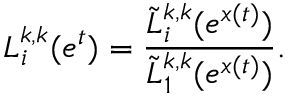Convert formula to latex. <formula><loc_0><loc_0><loc_500><loc_500>L _ { i } ^ { k , k } ( e ^ { t } ) = \frac { \tilde { L } _ { i } ^ { k , k } ( e ^ { x ( t ) } ) } { \tilde { L } _ { 1 } ^ { k , k } ( e ^ { x ( t ) } ) } .</formula> 